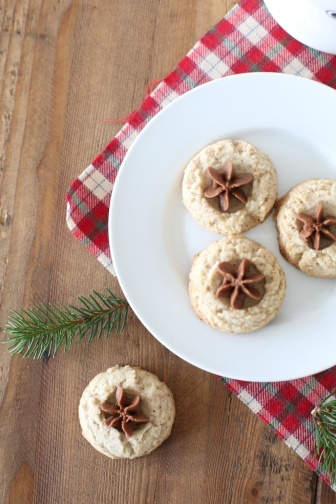Could you suggest a beverage that pairs well with these cookies? A fitting beverage to accompany these star anise-topped cookies could be a warm, spiced mulled wine or a cup of hot apple cider. Both options would complement the spices in the cookies and enhance the overall holiday experience. 